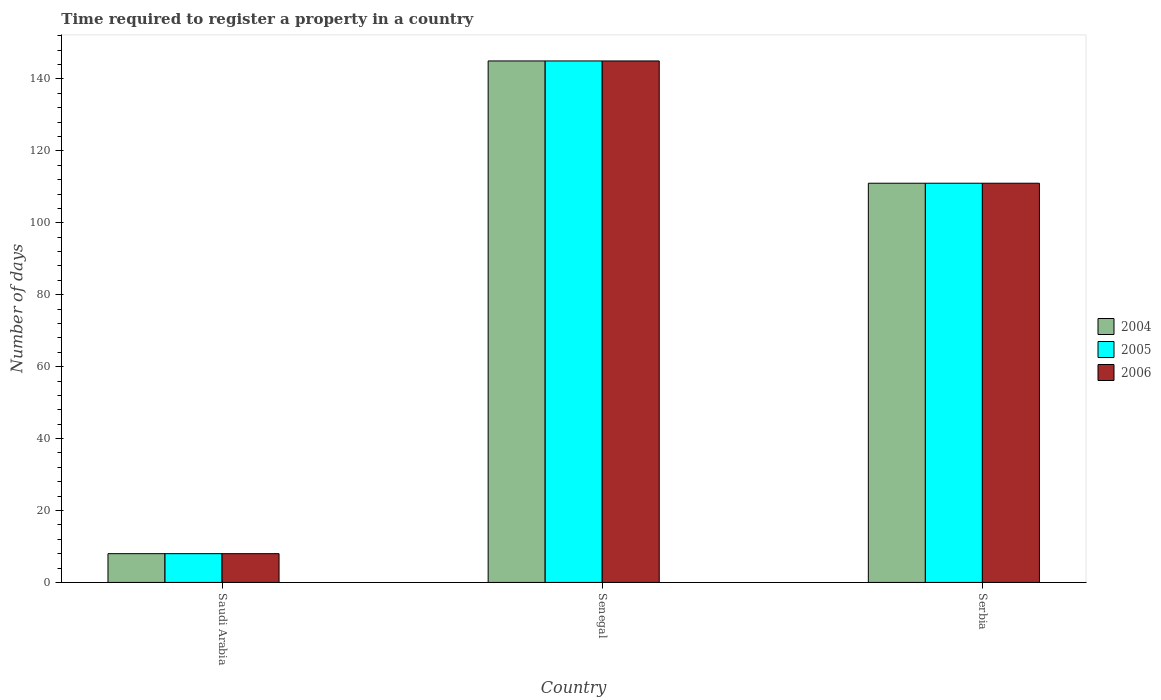How many different coloured bars are there?
Offer a terse response. 3. How many groups of bars are there?
Your answer should be very brief. 3. Are the number of bars per tick equal to the number of legend labels?
Your response must be concise. Yes. Are the number of bars on each tick of the X-axis equal?
Provide a short and direct response. Yes. What is the label of the 2nd group of bars from the left?
Your answer should be very brief. Senegal. In how many cases, is the number of bars for a given country not equal to the number of legend labels?
Provide a succinct answer. 0. What is the number of days required to register a property in 2006 in Serbia?
Your answer should be very brief. 111. Across all countries, what is the maximum number of days required to register a property in 2005?
Offer a very short reply. 145. Across all countries, what is the minimum number of days required to register a property in 2004?
Give a very brief answer. 8. In which country was the number of days required to register a property in 2005 maximum?
Ensure brevity in your answer.  Senegal. In which country was the number of days required to register a property in 2006 minimum?
Give a very brief answer. Saudi Arabia. What is the total number of days required to register a property in 2005 in the graph?
Give a very brief answer. 264. What is the difference between the number of days required to register a property in 2005 in Saudi Arabia and that in Serbia?
Your answer should be compact. -103. What is the difference between the number of days required to register a property in 2005 in Saudi Arabia and the number of days required to register a property in 2004 in Senegal?
Keep it short and to the point. -137. What is the average number of days required to register a property in 2004 per country?
Your answer should be compact. 88. What is the ratio of the number of days required to register a property in 2005 in Saudi Arabia to that in Senegal?
Ensure brevity in your answer.  0.06. Is the number of days required to register a property in 2005 in Saudi Arabia less than that in Serbia?
Make the answer very short. Yes. What is the difference between the highest and the second highest number of days required to register a property in 2005?
Offer a terse response. -137. What is the difference between the highest and the lowest number of days required to register a property in 2004?
Offer a very short reply. 137. Is the sum of the number of days required to register a property in 2005 in Saudi Arabia and Senegal greater than the maximum number of days required to register a property in 2006 across all countries?
Make the answer very short. Yes. What does the 2nd bar from the right in Senegal represents?
Offer a terse response. 2005. Is it the case that in every country, the sum of the number of days required to register a property in 2005 and number of days required to register a property in 2006 is greater than the number of days required to register a property in 2004?
Your answer should be compact. Yes. Where does the legend appear in the graph?
Your answer should be compact. Center right. How are the legend labels stacked?
Offer a very short reply. Vertical. What is the title of the graph?
Provide a succinct answer. Time required to register a property in a country. Does "1970" appear as one of the legend labels in the graph?
Provide a short and direct response. No. What is the label or title of the X-axis?
Make the answer very short. Country. What is the label or title of the Y-axis?
Offer a terse response. Number of days. What is the Number of days in 2004 in Saudi Arabia?
Offer a terse response. 8. What is the Number of days in 2005 in Saudi Arabia?
Provide a succinct answer. 8. What is the Number of days of 2004 in Senegal?
Your answer should be compact. 145. What is the Number of days in 2005 in Senegal?
Your answer should be very brief. 145. What is the Number of days in 2006 in Senegal?
Provide a succinct answer. 145. What is the Number of days of 2004 in Serbia?
Give a very brief answer. 111. What is the Number of days of 2005 in Serbia?
Ensure brevity in your answer.  111. What is the Number of days of 2006 in Serbia?
Give a very brief answer. 111. Across all countries, what is the maximum Number of days of 2004?
Provide a short and direct response. 145. Across all countries, what is the maximum Number of days of 2005?
Your response must be concise. 145. Across all countries, what is the maximum Number of days of 2006?
Make the answer very short. 145. What is the total Number of days of 2004 in the graph?
Ensure brevity in your answer.  264. What is the total Number of days in 2005 in the graph?
Ensure brevity in your answer.  264. What is the total Number of days in 2006 in the graph?
Provide a succinct answer. 264. What is the difference between the Number of days in 2004 in Saudi Arabia and that in Senegal?
Your answer should be compact. -137. What is the difference between the Number of days of 2005 in Saudi Arabia and that in Senegal?
Provide a succinct answer. -137. What is the difference between the Number of days of 2006 in Saudi Arabia and that in Senegal?
Ensure brevity in your answer.  -137. What is the difference between the Number of days in 2004 in Saudi Arabia and that in Serbia?
Give a very brief answer. -103. What is the difference between the Number of days of 2005 in Saudi Arabia and that in Serbia?
Offer a very short reply. -103. What is the difference between the Number of days of 2006 in Saudi Arabia and that in Serbia?
Offer a very short reply. -103. What is the difference between the Number of days of 2004 in Senegal and that in Serbia?
Provide a succinct answer. 34. What is the difference between the Number of days of 2004 in Saudi Arabia and the Number of days of 2005 in Senegal?
Ensure brevity in your answer.  -137. What is the difference between the Number of days in 2004 in Saudi Arabia and the Number of days in 2006 in Senegal?
Provide a succinct answer. -137. What is the difference between the Number of days of 2005 in Saudi Arabia and the Number of days of 2006 in Senegal?
Make the answer very short. -137. What is the difference between the Number of days of 2004 in Saudi Arabia and the Number of days of 2005 in Serbia?
Offer a terse response. -103. What is the difference between the Number of days of 2004 in Saudi Arabia and the Number of days of 2006 in Serbia?
Offer a terse response. -103. What is the difference between the Number of days in 2005 in Saudi Arabia and the Number of days in 2006 in Serbia?
Keep it short and to the point. -103. What is the difference between the Number of days in 2004 in Senegal and the Number of days in 2005 in Serbia?
Provide a succinct answer. 34. What is the difference between the Number of days of 2004 in Senegal and the Number of days of 2006 in Serbia?
Ensure brevity in your answer.  34. What is the difference between the Number of days in 2005 in Senegal and the Number of days in 2006 in Serbia?
Offer a very short reply. 34. What is the difference between the Number of days in 2004 and Number of days in 2005 in Saudi Arabia?
Make the answer very short. 0. What is the difference between the Number of days of 2004 and Number of days of 2005 in Senegal?
Provide a short and direct response. 0. What is the difference between the Number of days of 2004 and Number of days of 2006 in Senegal?
Make the answer very short. 0. What is the difference between the Number of days in 2005 and Number of days in 2006 in Serbia?
Ensure brevity in your answer.  0. What is the ratio of the Number of days of 2004 in Saudi Arabia to that in Senegal?
Give a very brief answer. 0.06. What is the ratio of the Number of days in 2005 in Saudi Arabia to that in Senegal?
Keep it short and to the point. 0.06. What is the ratio of the Number of days of 2006 in Saudi Arabia to that in Senegal?
Your response must be concise. 0.06. What is the ratio of the Number of days in 2004 in Saudi Arabia to that in Serbia?
Make the answer very short. 0.07. What is the ratio of the Number of days in 2005 in Saudi Arabia to that in Serbia?
Ensure brevity in your answer.  0.07. What is the ratio of the Number of days in 2006 in Saudi Arabia to that in Serbia?
Your answer should be very brief. 0.07. What is the ratio of the Number of days in 2004 in Senegal to that in Serbia?
Offer a terse response. 1.31. What is the ratio of the Number of days in 2005 in Senegal to that in Serbia?
Ensure brevity in your answer.  1.31. What is the ratio of the Number of days in 2006 in Senegal to that in Serbia?
Make the answer very short. 1.31. What is the difference between the highest and the second highest Number of days in 2004?
Your answer should be compact. 34. What is the difference between the highest and the second highest Number of days of 2005?
Your answer should be very brief. 34. What is the difference between the highest and the second highest Number of days in 2006?
Your answer should be compact. 34. What is the difference between the highest and the lowest Number of days of 2004?
Offer a terse response. 137. What is the difference between the highest and the lowest Number of days in 2005?
Ensure brevity in your answer.  137. What is the difference between the highest and the lowest Number of days of 2006?
Your answer should be compact. 137. 